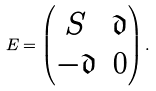<formula> <loc_0><loc_0><loc_500><loc_500>E = \begin{pmatrix} S & \mathfrak { d } \\ - \mathfrak { d } & 0 \end{pmatrix} .</formula> 